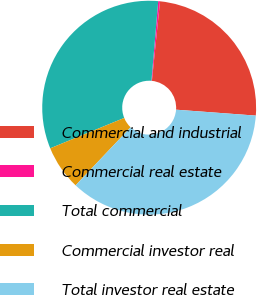<chart> <loc_0><loc_0><loc_500><loc_500><pie_chart><fcel>Commercial and industrial<fcel>Commercial real estate<fcel>Total commercial<fcel>Commercial investor real<fcel>Total investor real estate<nl><fcel>24.56%<fcel>0.27%<fcel>32.55%<fcel>6.73%<fcel>35.89%<nl></chart> 